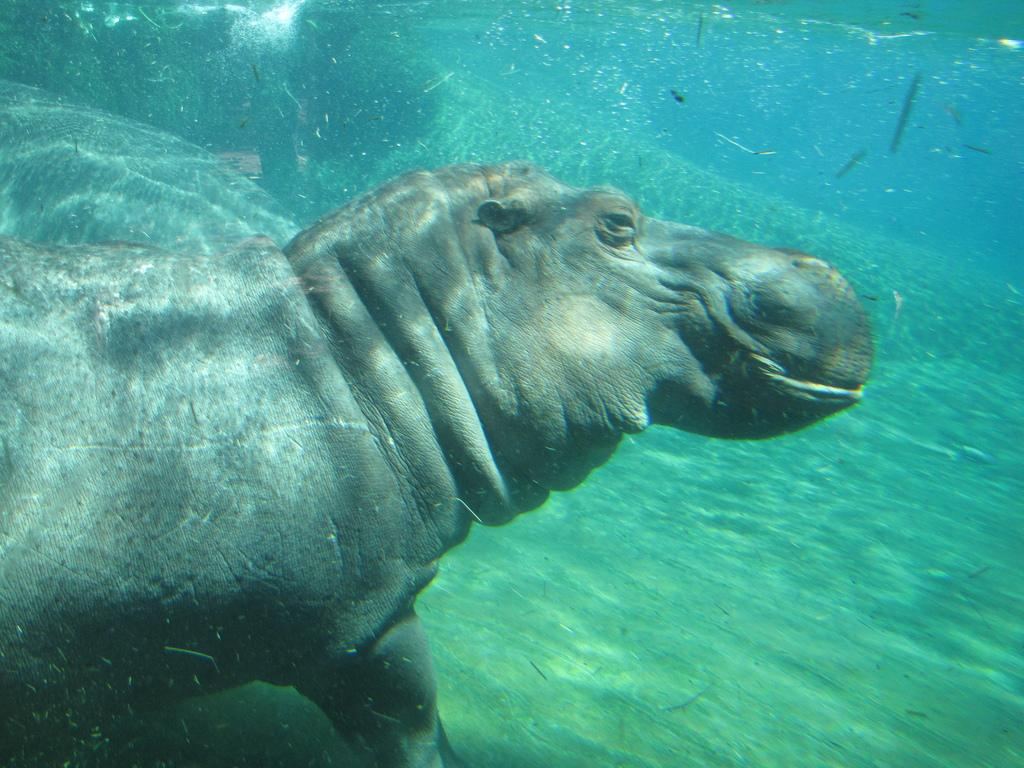What type of environment is depicted in the image? The image is an underwater picture. What kind of creature can be seen in the image? There is an aquatic animal visible in the image. Where is the aquatic animal located in the image? The aquatic animal is in the water. What type of steel structure can be seen in the image? There is no steel structure present in the image; it is an underwater picture featuring an aquatic animal. Can you tell me how many jellyfish are visible in the image? The provided facts do not mention jellyfish; only one aquatic animal is mentioned. 